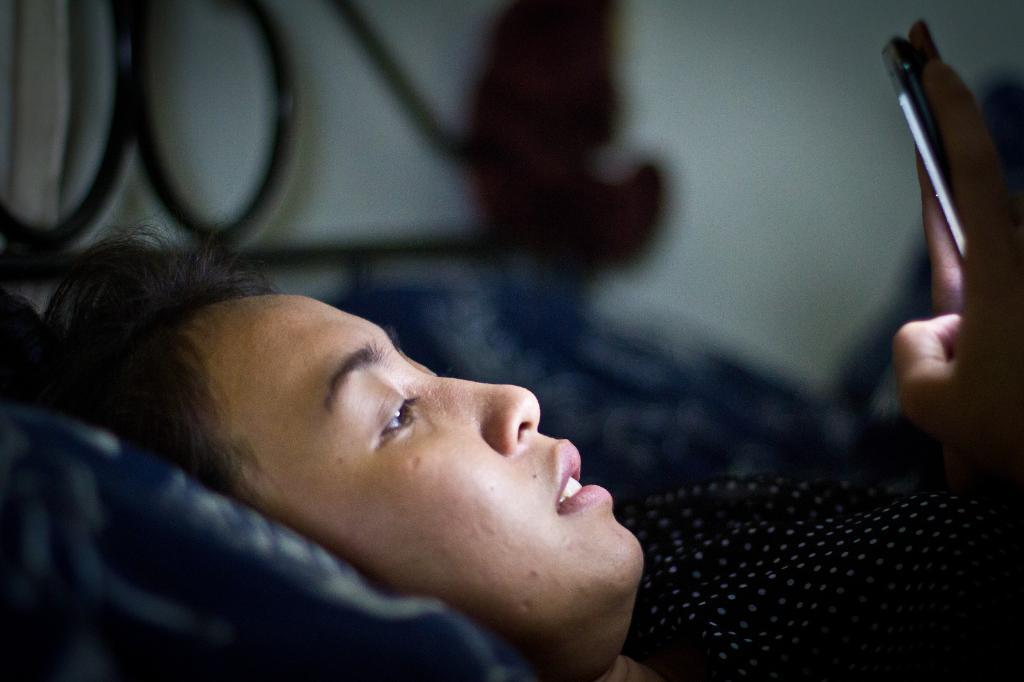Who is in the image? There is a lady in the image. What is the lady doing in the image? The lady is lying on a bed. What is the lady holding in her hand? The lady is holding a mobile in her hand. What can be seen at the top of the image? There is a wall present at the top of the image. What type of writing can be seen on the sign in the image? There is no sign present in the image, so no writing can be seen. 